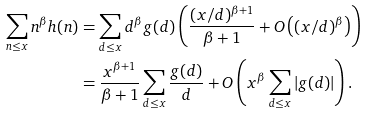<formula> <loc_0><loc_0><loc_500><loc_500>\sum _ { n \leq x } n ^ { \beta } h ( n ) & = \sum _ { d \leq x } d ^ { \beta } g ( d ) \left ( \frac { ( x / d ) ^ { \beta + 1 } } { \beta + 1 } + O \left ( ( x / d ) ^ { \beta } \right ) \right ) \\ & = \frac { x ^ { \beta + 1 } } { \beta + 1 } \sum _ { d \leq x } \frac { g ( d ) } d + O \left ( x ^ { \beta } \sum _ { d \leq x } | g ( d ) | \right ) .</formula> 